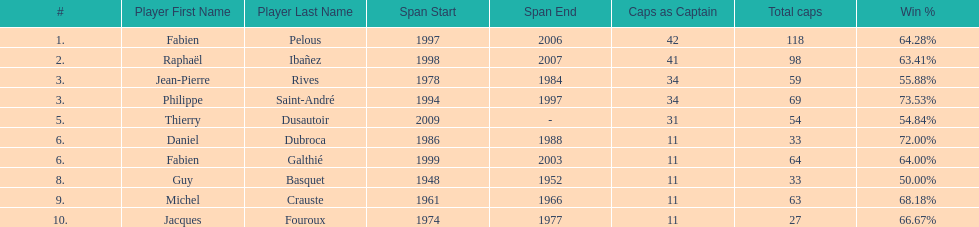Can you parse all the data within this table? {'header': ['#', 'Player First Name', 'Player Last Name', 'Span Start', 'Span End', 'Caps as Captain', 'Total caps', 'Win\xa0%'], 'rows': [['1.', 'Fabien', 'Pelous', '1997', '2006', '42', '118', '64.28%'], ['2.', 'Raphaël', 'Ibañez', '1998', '2007', '41', '98', '63.41%'], ['3.', 'Jean-Pierre', 'Rives', '1978', '1984', '34', '59', '55.88%'], ['3.', 'Philippe', 'Saint-André', '1994', '1997', '34', '69', '73.53%'], ['5.', 'Thierry', 'Dusautoir', '2009', '-', '31', '54', '54.84%'], ['6.', 'Daniel', 'Dubroca', '1986', '1988', '11', '33', '72.00%'], ['6.', 'Fabien', 'Galthié', '1999', '2003', '11', '64', '64.00%'], ['8.', 'Guy', 'Basquet', '1948', '1952', '11', '33', '50.00%'], ['9.', 'Michel', 'Crauste', '1961', '1966', '11', '63', '68.18%'], ['10.', 'Jacques', 'Fouroux', '1974', '1977', '11', '27', '66.67%']]} How many captains played 11 capped matches? 5. 